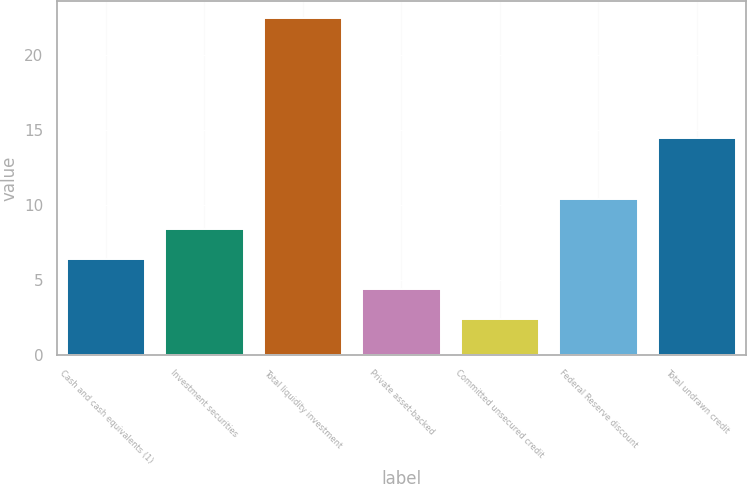Convert chart. <chart><loc_0><loc_0><loc_500><loc_500><bar_chart><fcel>Cash and cash equivalents (1)<fcel>Investment securities<fcel>Total liquidity investment<fcel>Private asset-backed<fcel>Committed unsecured credit<fcel>Federal Reserve discount<fcel>Total undrawn credit<nl><fcel>6.42<fcel>8.43<fcel>22.5<fcel>4.41<fcel>2.4<fcel>10.44<fcel>14.46<nl></chart> 